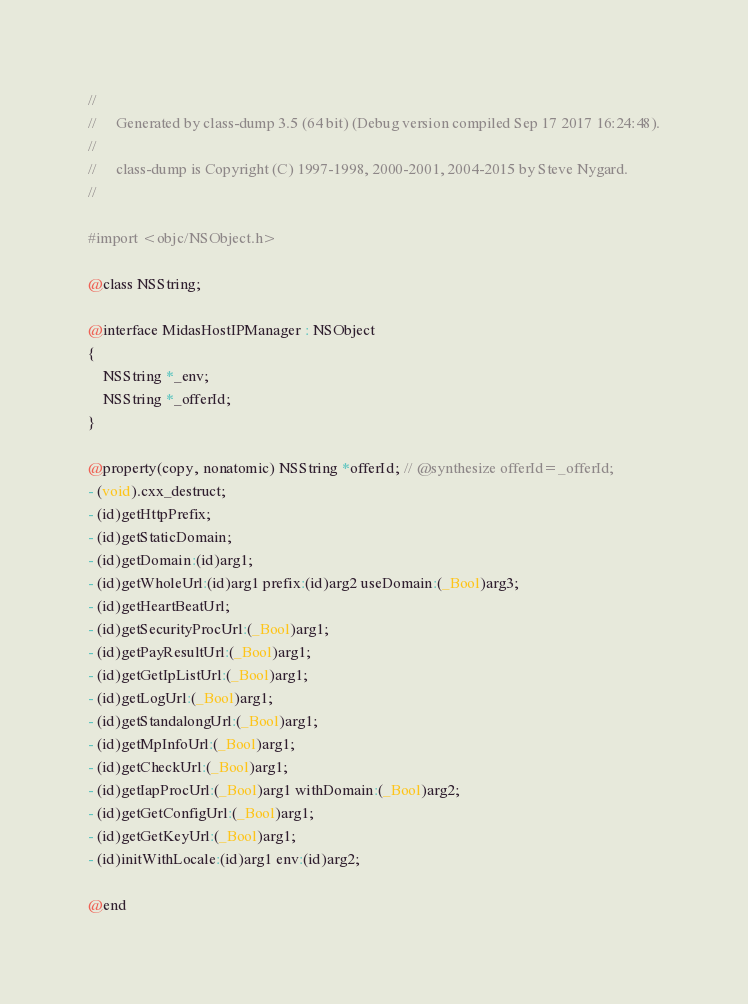Convert code to text. <code><loc_0><loc_0><loc_500><loc_500><_C_>//
//     Generated by class-dump 3.5 (64 bit) (Debug version compiled Sep 17 2017 16:24:48).
//
//     class-dump is Copyright (C) 1997-1998, 2000-2001, 2004-2015 by Steve Nygard.
//

#import <objc/NSObject.h>

@class NSString;

@interface MidasHostIPManager : NSObject
{
    NSString *_env;
    NSString *_offerId;
}

@property(copy, nonatomic) NSString *offerId; // @synthesize offerId=_offerId;
- (void).cxx_destruct;
- (id)getHttpPrefix;
- (id)getStaticDomain;
- (id)getDomain:(id)arg1;
- (id)getWholeUrl:(id)arg1 prefix:(id)arg2 useDomain:(_Bool)arg3;
- (id)getHeartBeatUrl;
- (id)getSecurityProcUrl:(_Bool)arg1;
- (id)getPayResultUrl:(_Bool)arg1;
- (id)getGetIpListUrl:(_Bool)arg1;
- (id)getLogUrl:(_Bool)arg1;
- (id)getStandalongUrl:(_Bool)arg1;
- (id)getMpInfoUrl:(_Bool)arg1;
- (id)getCheckUrl:(_Bool)arg1;
- (id)getIapProcUrl:(_Bool)arg1 withDomain:(_Bool)arg2;
- (id)getGetConfigUrl:(_Bool)arg1;
- (id)getGetKeyUrl:(_Bool)arg1;
- (id)initWithLocale:(id)arg1 env:(id)arg2;

@end

</code> 